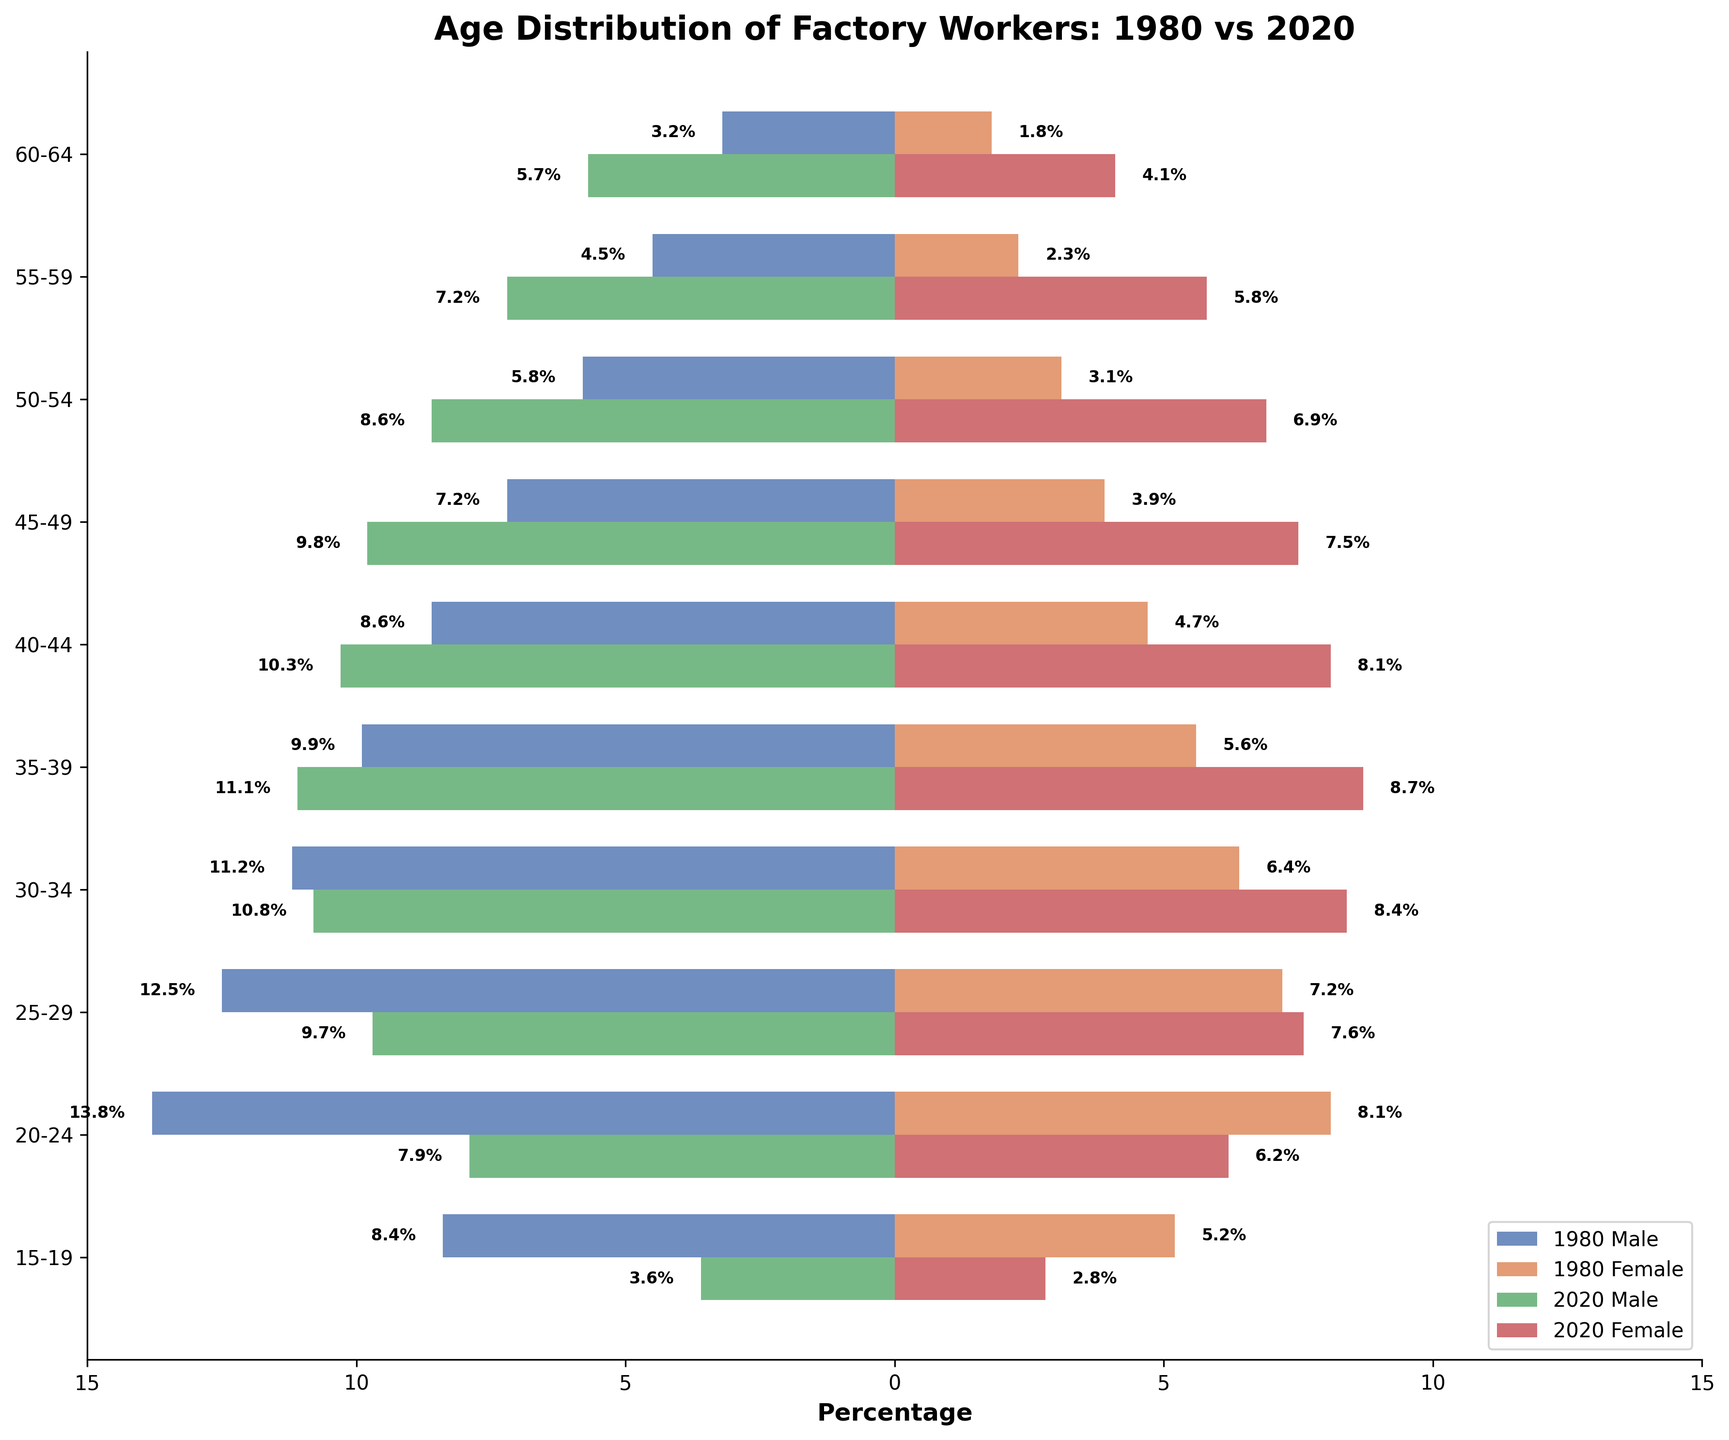What's the title of the figure? The title of the figure is always located at the top of the chart. In this case, it's "Age Distribution of Factory Workers: 1980 vs 2020".
Answer: Age Distribution of Factory Workers: 1980 vs 2020 In 1980, which age group had the highest percentage of male factory workers? Refer to the left-hand side of the figure and identify the bar that extends the most to the left for the 1980 male category. The age group with the highest percentage is 20-24.
Answer: 20-24 What is the difference in the percentage of female workers aged 45-49 between 1980 and 2020? Locate the bars corresponding to the 45-49 age group on the right-hand side for both 1980 and 2020 female workers. The difference is calculated as 7.5% (2020) - 3.9% (1980) = 3.6%.
Answer: 3.6% Which age group had the greatest increase in percentage for male workers from 1980 to 2020? Examine both 1980 and 2020 male bars and look for the largest positive difference. The greatest increase was in the 40-44 age group, from 8.6% in 1980 to 10.3% in 2020 (+1.7%).
Answer: 40-44 In 2020, which gender had a higher percentage of workers in the 35-39 age group? Compare the heights of the bars for males and females in the 35-39 age group in 2020 on either side of the y-axis. Males had 11.1% while females had 8.7%.
Answer: Male How many age groups had a lower percentage of female workers in 2020 compared to male workers in 1980 in the same age group? Count the age groups where the female percentage in 2020 is less than the male percentage in 1980. The applicable age groups are: 15-19, 20-24, 25-29. So there are three.
Answer: 3 Which age group in 1980 had approximately an equal percentage of male and female workers? Compare the bars for males and females within each age group for 1980. The age group 20-24 had 13.8% males and 8.1% females which are not approximately equal. Upon checking others, no groups are approximately equal.
Answer: None What percentage of male factory workers aged 50-54 is in 2020? The percentage is directly stated in the bar corresponding to the 50-54 age group for male workers in 2020 on the left-hand side of the y-axis. It’s 8.6%.
Answer: 8.6% In which age group is the decline in the population from 1980 to 2020 most noticeable for males? Find the age group where the amount of decrease is the largest by comparing the lengths of the bars. The 20-24 age group shows the biggest decline, from 13.8% to 7.9%, a difference of 5.9%.
Answer: 20-24 